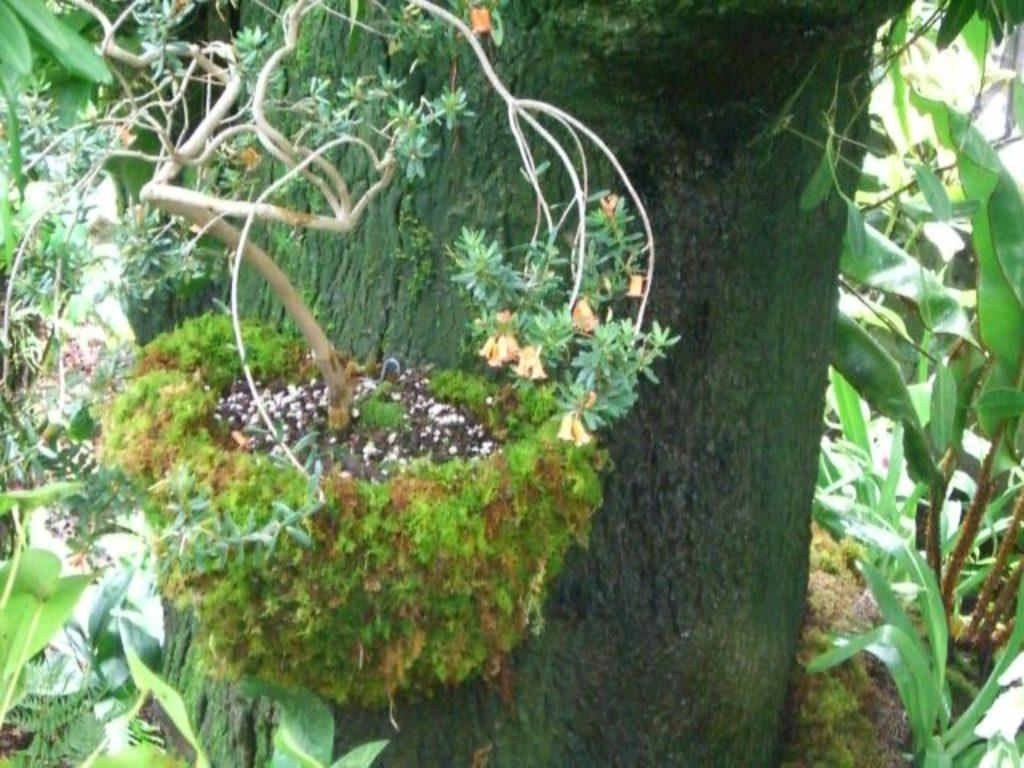What type of natural material is present in the image? There is tree bark in the image. What other natural elements can be seen in the image? There are plants and leaves in the image. What type of family activity is depicted in the image? There is no family activity depicted in the image; it only features tree bark, plants, and leaves. What type of tool is used for trade in the image? There is no tool or trade activity depicted in the image. 